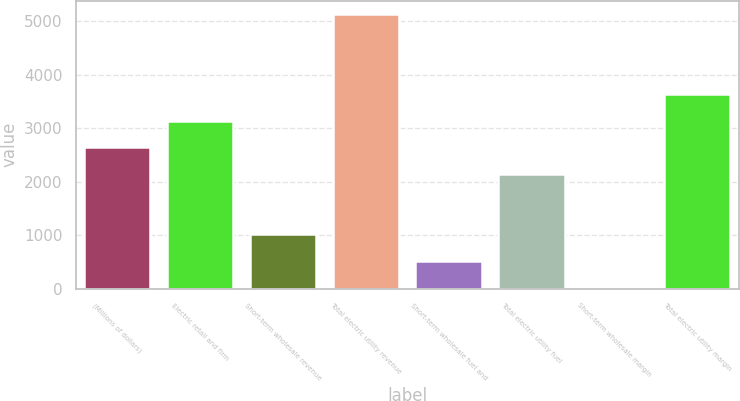Convert chart to OTSL. <chart><loc_0><loc_0><loc_500><loc_500><bar_chart><fcel>(Millions of dollars)<fcel>Electric retail and firm<fcel>Short-term wholesale revenue<fcel>Total electric utility revenue<fcel>Short-term wholesale fuel and<fcel>Total electric utility fuel<fcel>Short-term wholesale margin<fcel>Total electric utility margin<nl><fcel>2651<fcel>3146<fcel>1024<fcel>5133<fcel>529<fcel>2156<fcel>34<fcel>3641<nl></chart> 